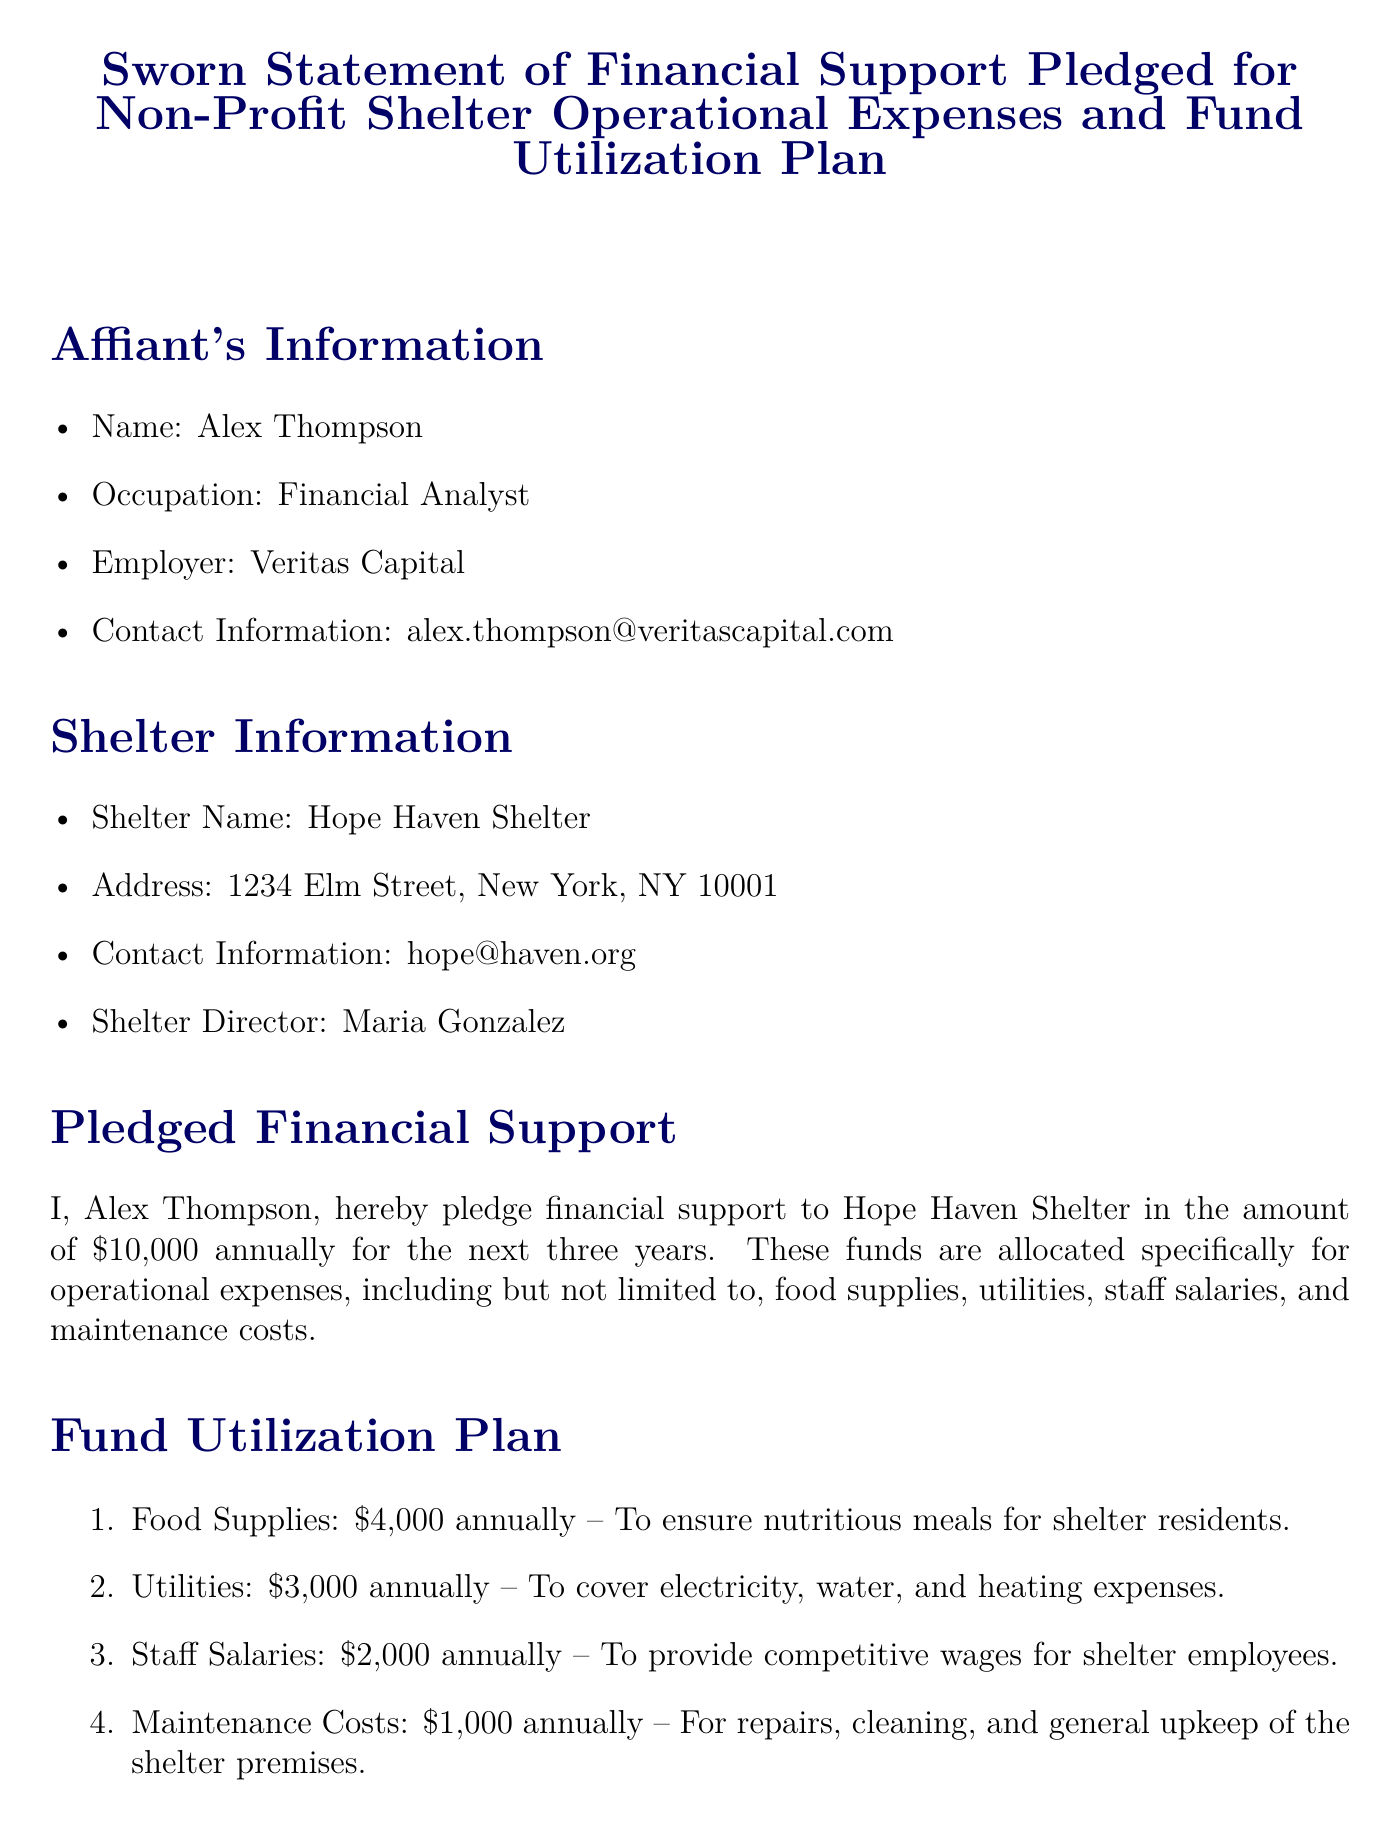What is the name of the affiant? The affiant is the person making the sworn statement, which is Alex Thompson.
Answer: Alex Thompson What is the pledged financial support amount? The pledged financial support amount for the shelter is stated explicitly in the document.
Answer: $10,000 How long is the financial support pledged for? This refers to the duration for which the affiant has committed the financial support, as indicated in the document.
Answer: Three years What is the main purpose of the funds? The purpose of the funds can be derived from the context provided in the pledged financial support section.
Answer: Operational expenses What is the allocation for food supplies annually? This refers to a specific component of the fund utilization plan that is detailed in the document.
Answer: $4,000 Who is the Shelter Director? The Shelter Director is the individual in charge of the shelter, as listed in the shelter information.
Answer: Maria Gonzalez What percentage of the total annual support is allocated to maintenance costs? This question assesses the understanding of the fund allocation based on the total pledged support and specific allocations.
Answer: 10% What is the email address of the affiant? The email address is listed in the affiant's information section.
Answer: alex.thompson@veritascapital.com What is explicitly mentioned about the utilization of funds? This question targets the main commitment regarding the use of pledged funds as indicated in the document.
Answer: Effective and transparent use 